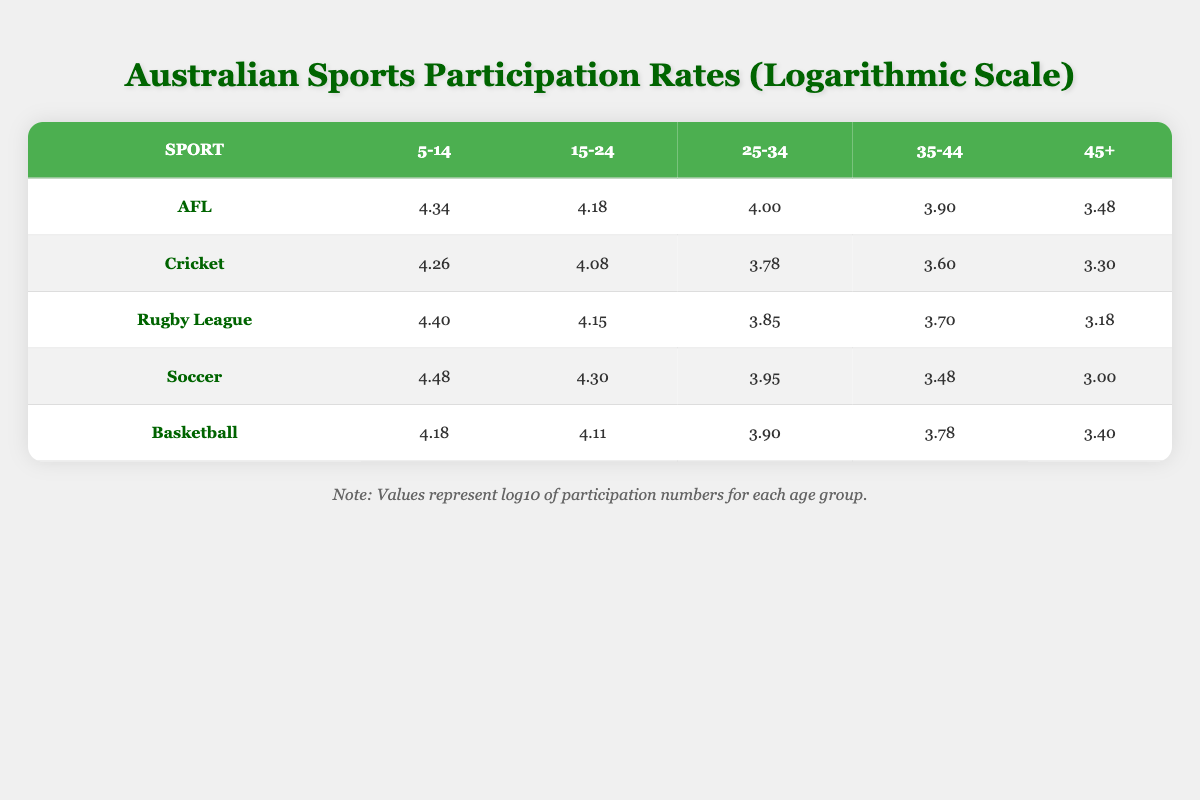What is the participation rate for Soccer in the 15-24 age group? According to the table, the participation rate for Soccer in the 15-24 age group is 4.30.
Answer: 4.30 Which sport has the highest participation rate among 5-14-year-olds? Looking at the table, Soccer has the highest value at 4.48 in the 5-14 age group.
Answer: Soccer What is the difference in participation rates between Rugby League and Cricket for the 35-44 age group? The participation rate for Rugby League in the 35-44 age group is 3.70, and for Cricket, it is 3.60. Subtracting the two gives us 3.70 - 3.60 = 0.10.
Answer: 0.10 Is the participation rate for Basketball greater than that for AFL in the 25-34 age group? The participation rate for Basketball in the 25-34 age group is 3.90 and for AFL, it is 4.00. Comparing these values shows that 3.90 is less than 4.00.
Answer: No What is the average participation rate across all sports for the 45+ age group? For the 45+ age group, the rates are: AFL (3.48), Cricket (3.30), Rugby League (3.18), Soccer (3.00), and Basketball (3.40). Summing these gives 3.48 + 3.30 + 3.18 + 3.00 + 3.40 = 16.36. There are 5 values, so the average is 16.36 / 5 = 3.272.
Answer: 3.272 Which age group has the lowest overall participation rates for AFL? In the AFL participation data, the 45+ age group has the lowest value of 3.48.
Answer: 45+ What is the cumulative participation rate for Rugby League across all age groups? The participation rates for Rugby League across all age groups are 4.40 (5-14), 4.15 (15-24), 3.85 (25-34), 3.70 (35-44), and 3.18 (45+). Summing these gives 4.40 + 4.15 + 3.85 + 3.70 + 3.18 = 19.28.
Answer: 19.28 Does Cricket have a higher participation rate than Soccer for the age group 25-34? For Cricket, the participation rate for the 25-34 age group is 3.78, while for Soccer it is 3.95. Since 3.78 is less than 3.95, Cricket does not have a higher rate.
Answer: No 